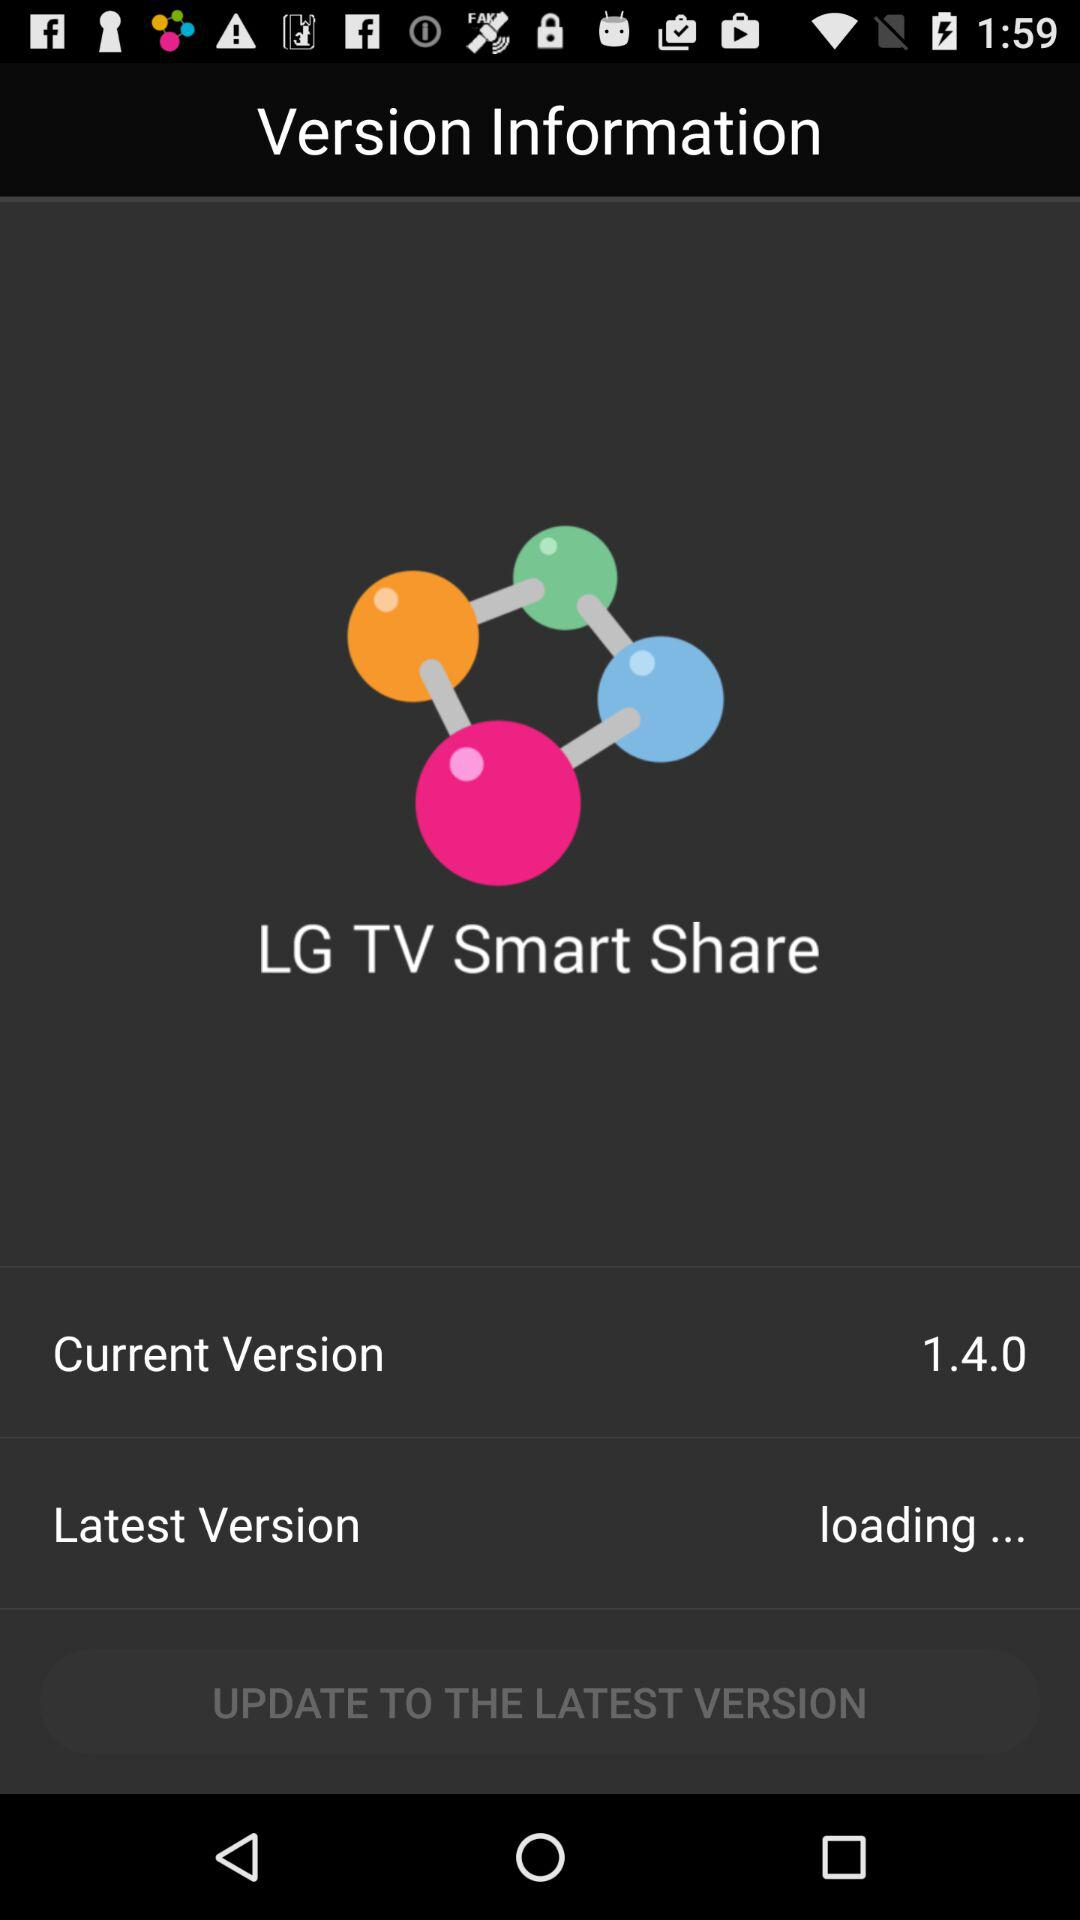What is the status of "Latest Version"? The status is "loading". 